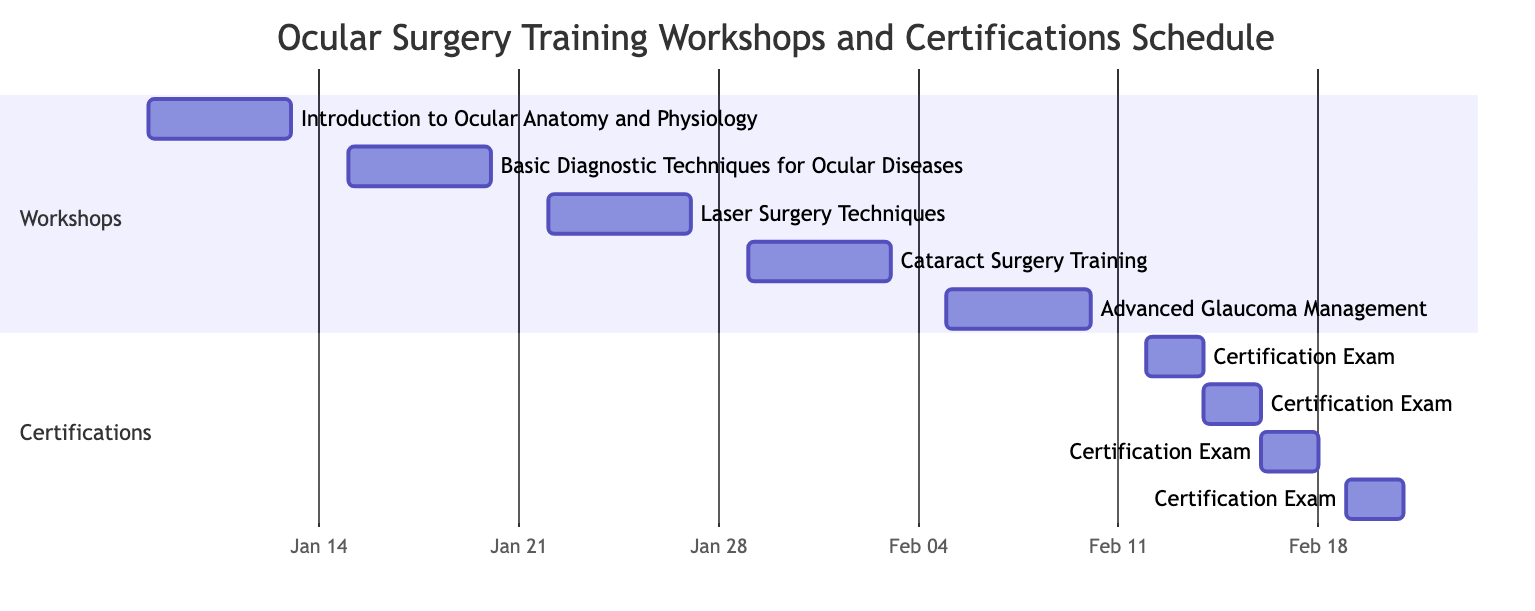What is the duration of the workshop on Laser Surgery Techniques? The duration is specified in the "duration_days" field for the workshop titled "Laser Surgery Techniques," which states that it lasts for 5 days.
Answer: 5 days When does the Advanced Glaucoma Management workshop start? The start date for the Advanced Glaucoma Management workshop is given in its details, which lists the start date as February 5, 2024.
Answer: February 5, 2024 How many certification exams are scheduled after February 15, 2024? By checking the certification exam dates listed, one can see that there are two certification exams scheduled after February 15, 2024: the Certification Exam for Cataract Surgery on February 16-17 and Advanced Glaucoma Management on February 19-20.
Answer: 2 Which workshop directly precedes the Certification Exam for Basic Diagnostic Techniques? The workshop completed just before this certification exam is the Basic Diagnostic Techniques for Ocular Diseases, ending on January 19, 2024. The exam is scheduled for February 12, 2024, which comes after this workshop.
Answer: Basic Diagnostic Techniques for Ocular Diseases What is the total duration of all workshops combined? To determine the total duration, add up the duration of each workshop: 5 days (for each of the 5 workshops) results in a total of 5 * 5 = 25 days.
Answer: 25 days What is the longest duration among the workshops? All workshops have the same duration of 5 days, thus the longest duration is 5 days, as all workshops last an equal amount of time.
Answer: 5 days Which certification exams occur consecutively in February 2024? By examining the dates for certification exams, we observe that the Certification Exam for Laser Surgery Techniques follows immediately after the Basic Diagnostic Techniques exam with no gaps: February 12-13 for Basic and February 14-15 for Laser, making them consecutive.
Answer: Basic Diagnostic Techniques and Laser Surgery Techniques What is the earliest scheduled date for any certification exam? The earliest certification exam is listed with the start date of February 12, 2024, which is for the Basic Diagnostic Techniques certification.
Answer: February 12, 2024 